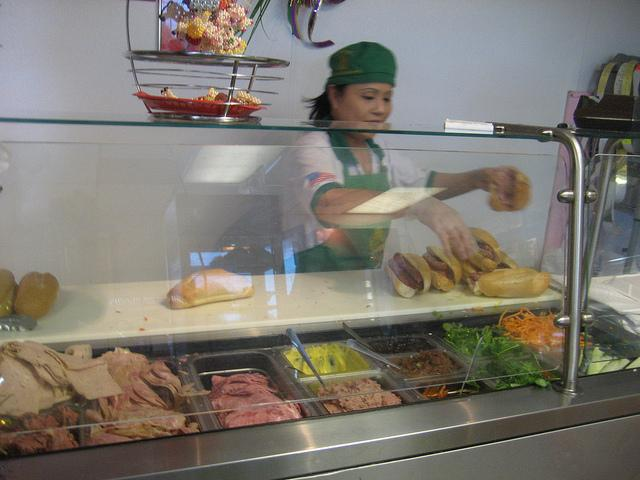What sort of specialty business is this? Please explain your reasoning. sandwich shop. The counter has many sandwiches on it which the woman has made, and the display is filled with sandwich items, indicating this is a shop to purchase sandwiches. 